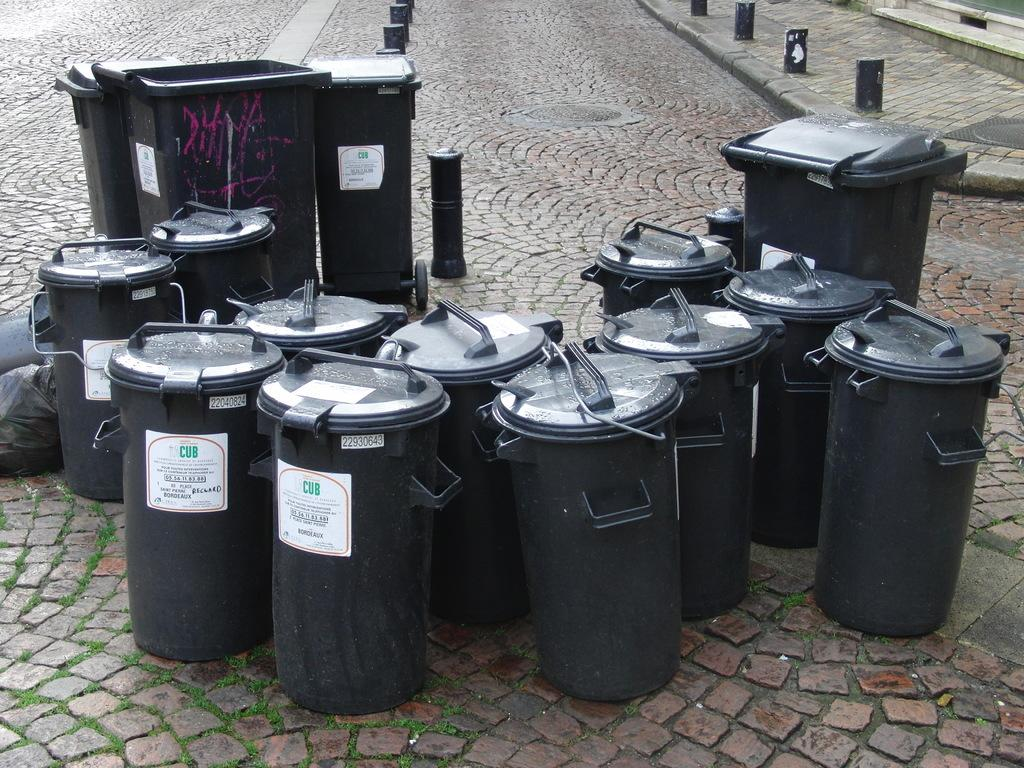<image>
Share a concise interpretation of the image provided. many trash cans reading CUB on the label in the cobble stone street 